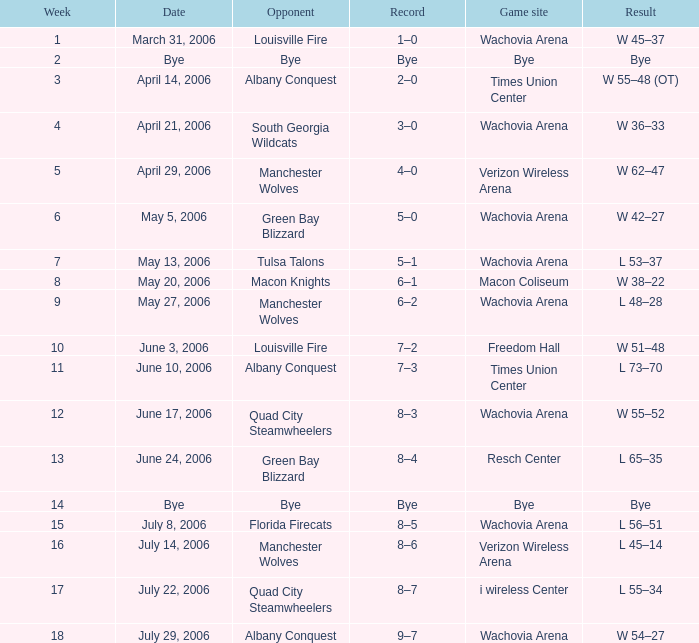What team was the opponent in a week earlier than 17 on June 17, 2006? Quad City Steamwheelers. Could you parse the entire table as a dict? {'header': ['Week', 'Date', 'Opponent', 'Record', 'Game site', 'Result'], 'rows': [['1', 'March 31, 2006', 'Louisville Fire', '1–0', 'Wachovia Arena', 'W 45–37'], ['2', 'Bye', 'Bye', 'Bye', 'Bye', 'Bye'], ['3', 'April 14, 2006', 'Albany Conquest', '2–0', 'Times Union Center', 'W 55–48 (OT)'], ['4', 'April 21, 2006', 'South Georgia Wildcats', '3–0', 'Wachovia Arena', 'W 36–33'], ['5', 'April 29, 2006', 'Manchester Wolves', '4–0', 'Verizon Wireless Arena', 'W 62–47'], ['6', 'May 5, 2006', 'Green Bay Blizzard', '5–0', 'Wachovia Arena', 'W 42–27'], ['7', 'May 13, 2006', 'Tulsa Talons', '5–1', 'Wachovia Arena', 'L 53–37'], ['8', 'May 20, 2006', 'Macon Knights', '6–1', 'Macon Coliseum', 'W 38–22'], ['9', 'May 27, 2006', 'Manchester Wolves', '6–2', 'Wachovia Arena', 'L 48–28'], ['10', 'June 3, 2006', 'Louisville Fire', '7–2', 'Freedom Hall', 'W 51–48'], ['11', 'June 10, 2006', 'Albany Conquest', '7–3', 'Times Union Center', 'L 73–70'], ['12', 'June 17, 2006', 'Quad City Steamwheelers', '8–3', 'Wachovia Arena', 'W 55–52'], ['13', 'June 24, 2006', 'Green Bay Blizzard', '8–4', 'Resch Center', 'L 65–35'], ['14', 'Bye', 'Bye', 'Bye', 'Bye', 'Bye'], ['15', 'July 8, 2006', 'Florida Firecats', '8–5', 'Wachovia Arena', 'L 56–51'], ['16', 'July 14, 2006', 'Manchester Wolves', '8–6', 'Verizon Wireless Arena', 'L 45–14'], ['17', 'July 22, 2006', 'Quad City Steamwheelers', '8–7', 'i wireless Center', 'L 55–34'], ['18', 'July 29, 2006', 'Albany Conquest', '9–7', 'Wachovia Arena', 'W 54–27']]} 